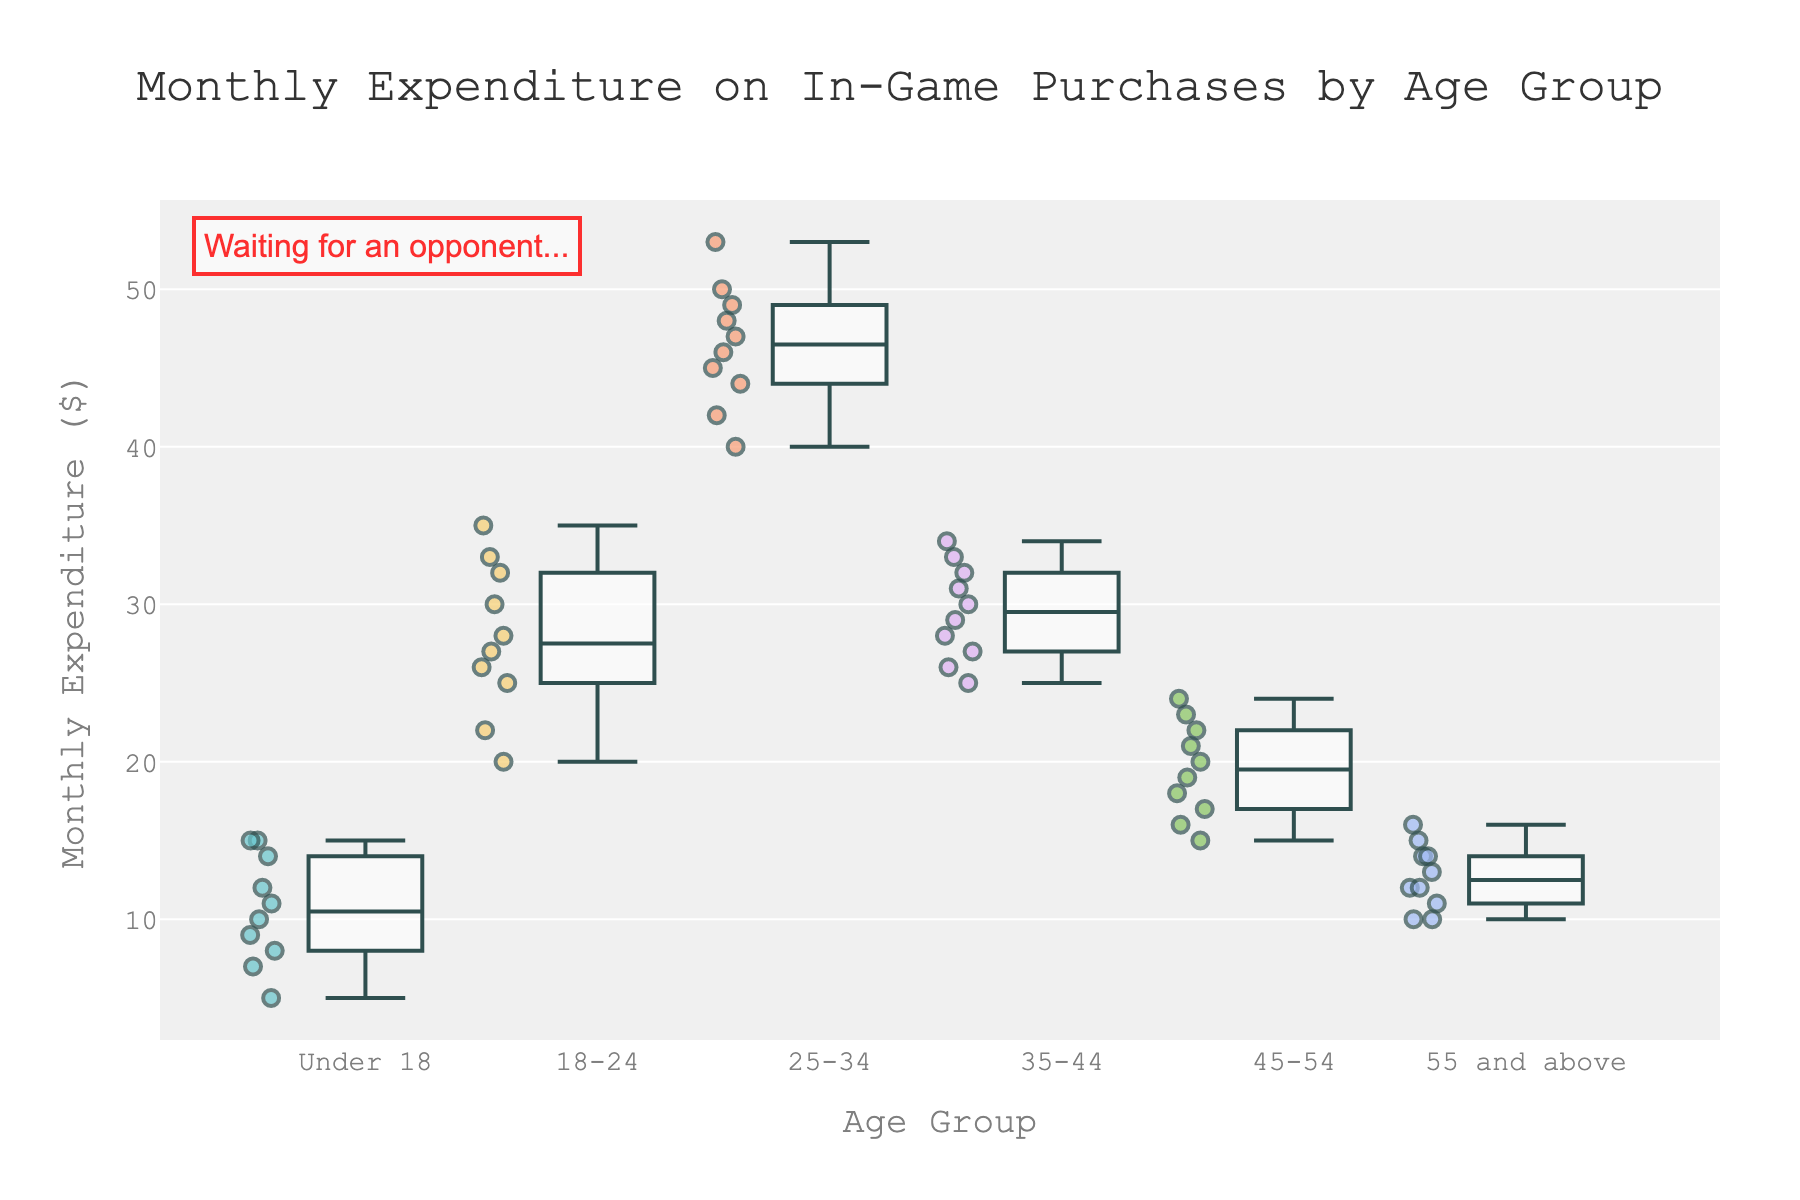Which age group has the highest median monthly expenditure? The median is the middle value when data points are ordered. For the 25-34 age group, the box is highest, indicating the highest median.
Answer: 25-34 What's the title of the plot? The title is usually found at the top of a plot, and it describes the main content of the figure. The title here is "Monthly Expenditure on In-Game Purchases by Age Group".
Answer: Monthly Expenditure on In-Game Purchases by Age Group How does the range of monthly expenditure for the 45-54 age group compare to the Under 18 group? The range is the difference between the minimum and maximum values within the box. For 45-54, it spans from 15 to 24, while for Under 18, it spans from 5 to 15.
Answer: 45-54 has a smaller range What does the annotation at the top left of the plot say? Annotations provide additional context or information and are often placed on the plot area itself. Here, the annotation states "Waiting for an opponent...".
Answer: Waiting for an opponent.. Which age group has the lowest maximum monthly expenditure? To find the maximum monthly expenditure, look at the top whisker of each box plot. The age group with the lowest top whisker is "Under 18".
Answer: Under 18 Compare the interquartile range (IQR) of the 18-24 and 25-34 age groups. IQR is the range within the box (Q3-Q1). For 18-24, if you look closely, it spans a smaller box compared to the much larger IQR for the 25-34 group.
Answer: 18-24 has a smaller IQR Which age group shows the least variability in monthly expenditure? Variability can be assessed by looking at the spread of the whiskers and the box. The 55 and above group has the smallest spread, indicating the least variability.
Answer: 55 and above What's the median value of the 35-44 age group? The median is the line inside the box. In the 35-44 age group, the median line appears to be at 30.
Answer: 30 